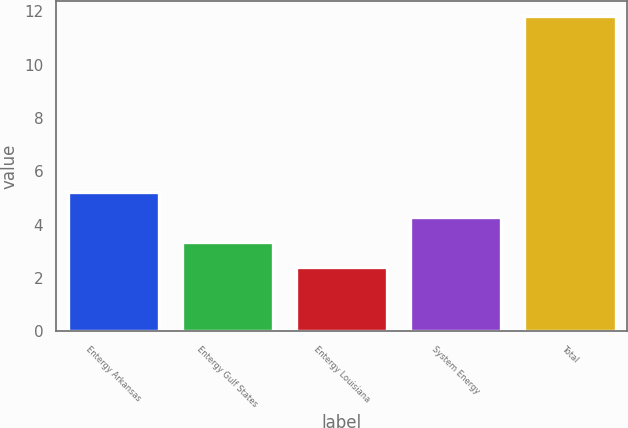Convert chart to OTSL. <chart><loc_0><loc_0><loc_500><loc_500><bar_chart><fcel>Entergy Arkansas<fcel>Entergy Gulf States<fcel>Entergy Louisiana<fcel>System Energy<fcel>Total<nl><fcel>5.22<fcel>3.34<fcel>2.4<fcel>4.28<fcel>11.8<nl></chart> 